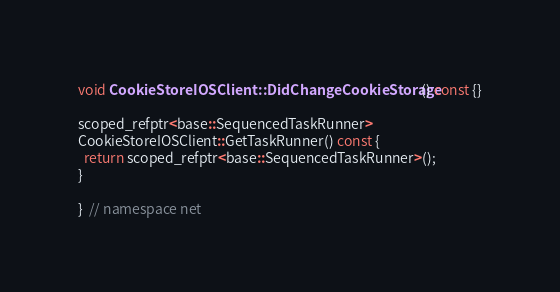Convert code to text. <code><loc_0><loc_0><loc_500><loc_500><_ObjectiveC_>
void CookieStoreIOSClient::DidChangeCookieStorage() const {}

scoped_refptr<base::SequencedTaskRunner>
CookieStoreIOSClient::GetTaskRunner() const {
  return scoped_refptr<base::SequencedTaskRunner>();
}

}  // namespace net
</code> 